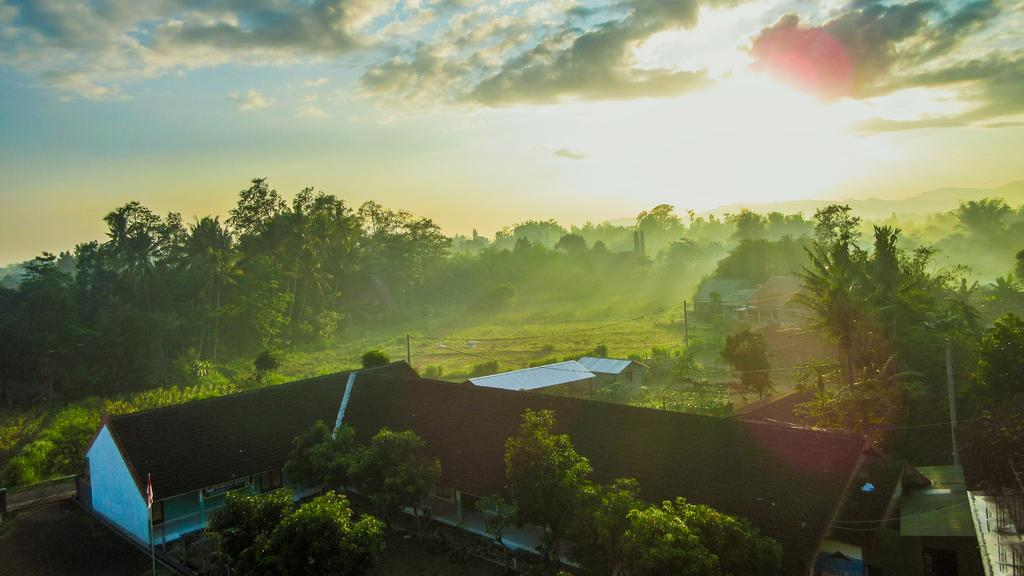What can be seen in the foreground of the image? There are houses, trees, and poles in the foreground of the image. What type of vegetation is present in the foreground? Trees are present in the foreground of the image. What is visible in the background of the image? Greenery is visible in the background of the image. What can be seen in the sky in the image? The sky is visible in the image, with clouds and the sun present. What type of card is being used to write someone's name on the juice in the image? There is no card, name, or juice present in the image. What type of juice is being served in the image? There is no juice present in the image. 